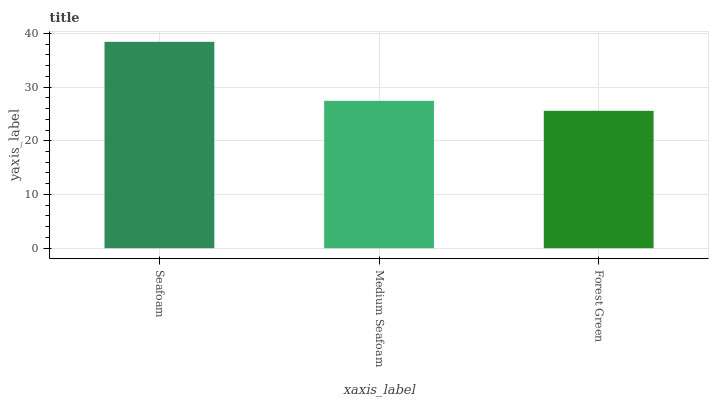Is Forest Green the minimum?
Answer yes or no. Yes. Is Seafoam the maximum?
Answer yes or no. Yes. Is Medium Seafoam the minimum?
Answer yes or no. No. Is Medium Seafoam the maximum?
Answer yes or no. No. Is Seafoam greater than Medium Seafoam?
Answer yes or no. Yes. Is Medium Seafoam less than Seafoam?
Answer yes or no. Yes. Is Medium Seafoam greater than Seafoam?
Answer yes or no. No. Is Seafoam less than Medium Seafoam?
Answer yes or no. No. Is Medium Seafoam the high median?
Answer yes or no. Yes. Is Medium Seafoam the low median?
Answer yes or no. Yes. Is Forest Green the high median?
Answer yes or no. No. Is Forest Green the low median?
Answer yes or no. No. 